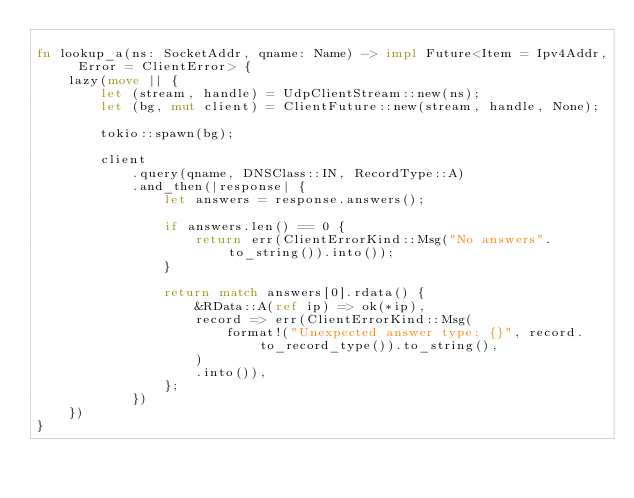Convert code to text. <code><loc_0><loc_0><loc_500><loc_500><_Rust_>
fn lookup_a(ns: SocketAddr, qname: Name) -> impl Future<Item = Ipv4Addr, Error = ClientError> {
    lazy(move || {
        let (stream, handle) = UdpClientStream::new(ns);
        let (bg, mut client) = ClientFuture::new(stream, handle, None);

        tokio::spawn(bg);

        client
            .query(qname, DNSClass::IN, RecordType::A)
            .and_then(|response| {
                let answers = response.answers();

                if answers.len() == 0 {
                    return err(ClientErrorKind::Msg("No answers".to_string()).into());
                }

                return match answers[0].rdata() {
                    &RData::A(ref ip) => ok(*ip),
                    record => err(ClientErrorKind::Msg(
                        format!("Unexpected answer type; {}", record.to_record_type()).to_string(),
                    )
                    .into()),
                };
            })
    })
}
</code> 